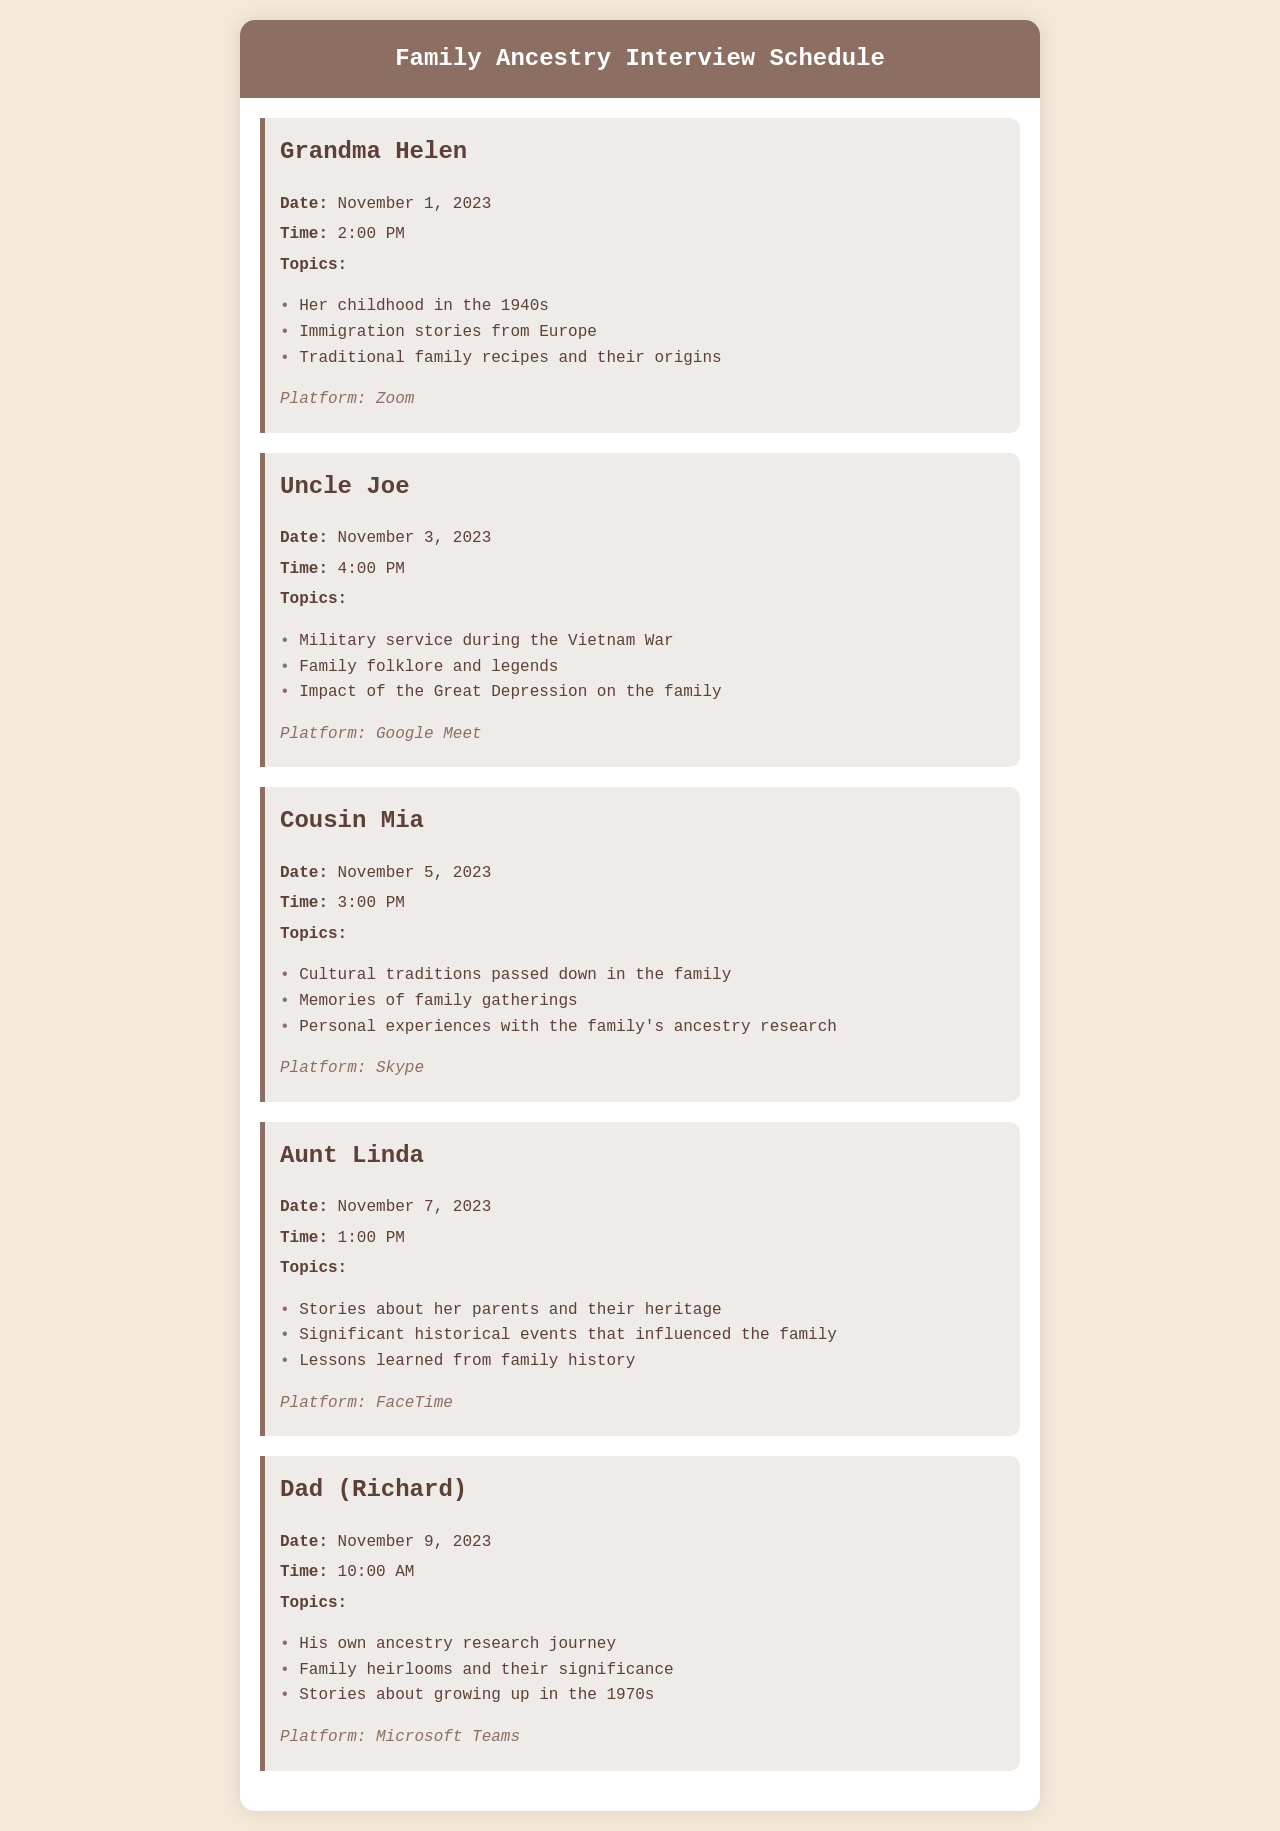What is the first interview date? The first interview is scheduled with Grandma Helen on November 1, 2023.
Answer: November 1, 2023 Who is being interviewed on November 3, 2023? The interview scheduled for November 3, 2023, is with Uncle Joe.
Answer: Uncle Joe How many topics will be discussed with Aunt Linda? Aunt Linda's interview includes three topics listed in the document.
Answer: Three What platform will be used for Cousin Mia's interview? The platform for Cousin Mia's interview is specified as Skype in the document.
Answer: Skype Which family member's stories focus on military service? The interview with Uncle Joe focuses on military service during the Vietnam War.
Answer: Uncle Joe What time is Dad's interview scheduled for? Dad's interview is set for 10:00 AM according to the schedule.
Answer: 10:00 AM How many family members are interviewed in total? Five family members are listed as part of the interview schedule.
Answer: Five What topic does Grandma Helen's interview include related to food? One of the topics for Grandma Helen's interview involves traditional family recipes and their origins.
Answer: Traditional family recipes and their origins What significant historical event is mentioned in Aunt Linda’s topics? One of Aunt Linda's topics includes significant historical events that influenced the family.
Answer: Significant historical events 